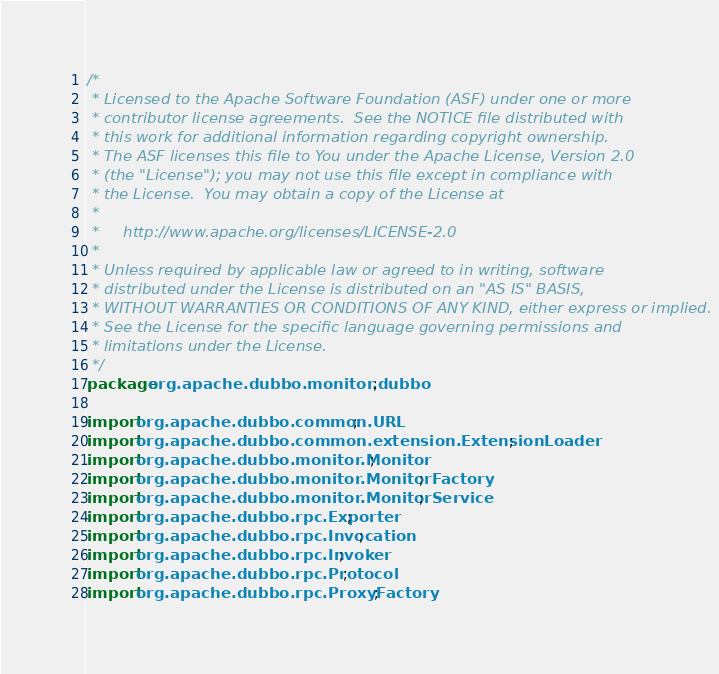Convert code to text. <code><loc_0><loc_0><loc_500><loc_500><_Java_>/*
 * Licensed to the Apache Software Foundation (ASF) under one or more
 * contributor license agreements.  See the NOTICE file distributed with
 * this work for additional information regarding copyright ownership.
 * The ASF licenses this file to You under the Apache License, Version 2.0
 * (the "License"); you may not use this file except in compliance with
 * the License.  You may obtain a copy of the License at
 *
 *     http://www.apache.org/licenses/LICENSE-2.0
 *
 * Unless required by applicable law or agreed to in writing, software
 * distributed under the License is distributed on an "AS IS" BASIS,
 * WITHOUT WARRANTIES OR CONDITIONS OF ANY KIND, either express or implied.
 * See the License for the specific language governing permissions and
 * limitations under the License.
 */
package org.apache.dubbo.monitor.dubbo;

import org.apache.dubbo.common.URL;
import org.apache.dubbo.common.extension.ExtensionLoader;
import org.apache.dubbo.monitor.Monitor;
import org.apache.dubbo.monitor.MonitorFactory;
import org.apache.dubbo.monitor.MonitorService;
import org.apache.dubbo.rpc.Exporter;
import org.apache.dubbo.rpc.Invocation;
import org.apache.dubbo.rpc.Invoker;
import org.apache.dubbo.rpc.Protocol;
import org.apache.dubbo.rpc.ProxyFactory;</code> 